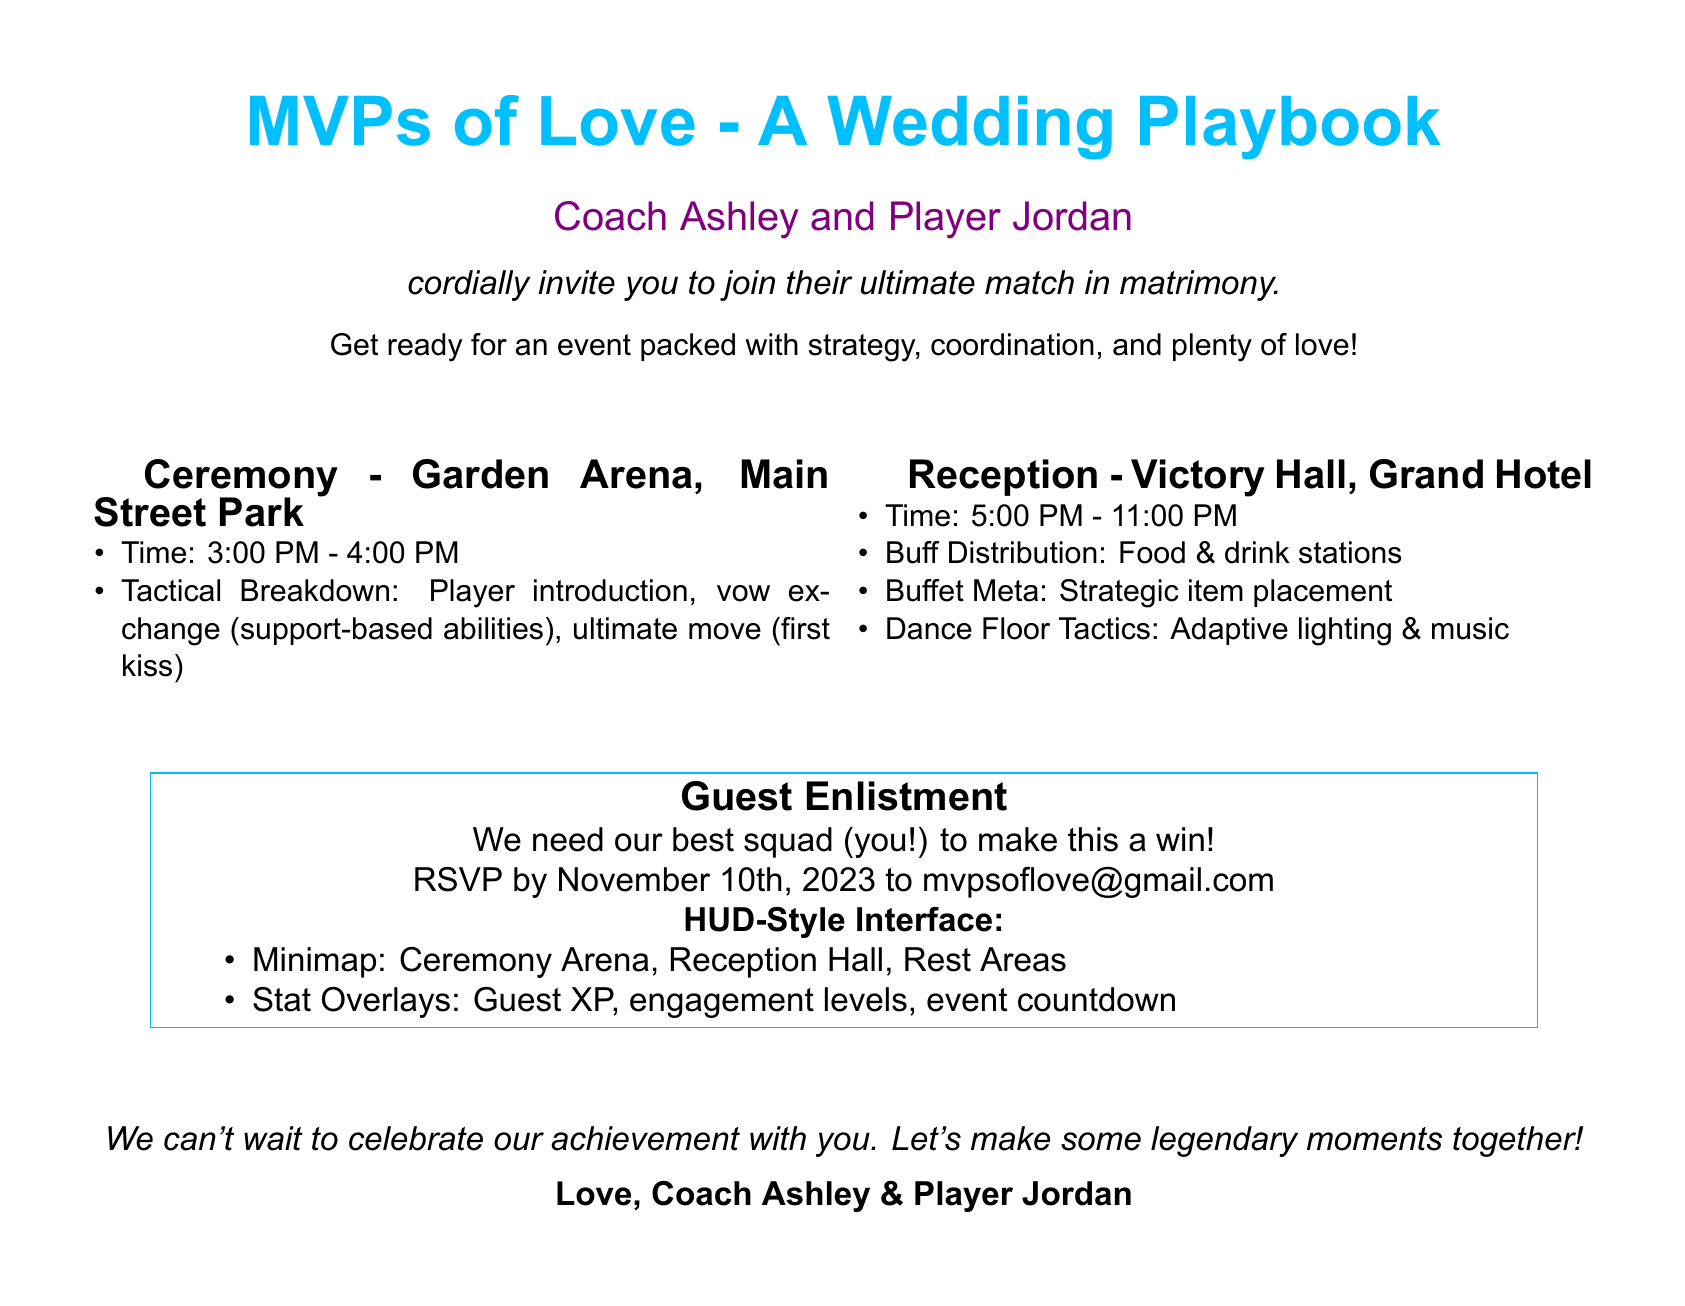What is the title of the document? The title is prominently displayed at the top of the document and indicates the theme of the invitation.
Answer: MVPs of Love - A Wedding Playbook Who are the hosts of the wedding? The hosts are introduced directly after the title, providing their names in a playful manner.
Answer: Coach Ashley and Player Jordan What time does the ceremony start? The ceremony time is specified in the section detailing the ceremony's schedule.
Answer: 3:00 PM Where is the reception held? The reception location is clearly mentioned in the reception section of the invitation.
Answer: Victory Hall, Grand Hotel What is the RSVP deadline? The RSVP deadline is stated clearly as part of the guest enlistment instructions.
Answer: November 10th, 2023 What type of tactics are mentioned for the dance floor? The document describes adaptive strategies for the ambiance of the dance floor.
Answer: Adaptive lighting & music How long is the reception scheduled to last? The duration of the reception is indicated by the start and end times provided in the document.
Answer: 6 hours What color is associated with the theme of the wedding? The theme colors are defined through the use of specific colors in the headings and section titles.
Answer: Gaming blue What is the purpose of the 'HUD-Style Interface'? This term is used to describe a thematic element of the invitation relating to guest engagement and event navigation.
Answer: Guest engagement and suggestions What is the ‘ultimate move’ in the ceremony? The ultimate move is a creative way to describe the couple’s first kiss during the ceremony.
Answer: First kiss 